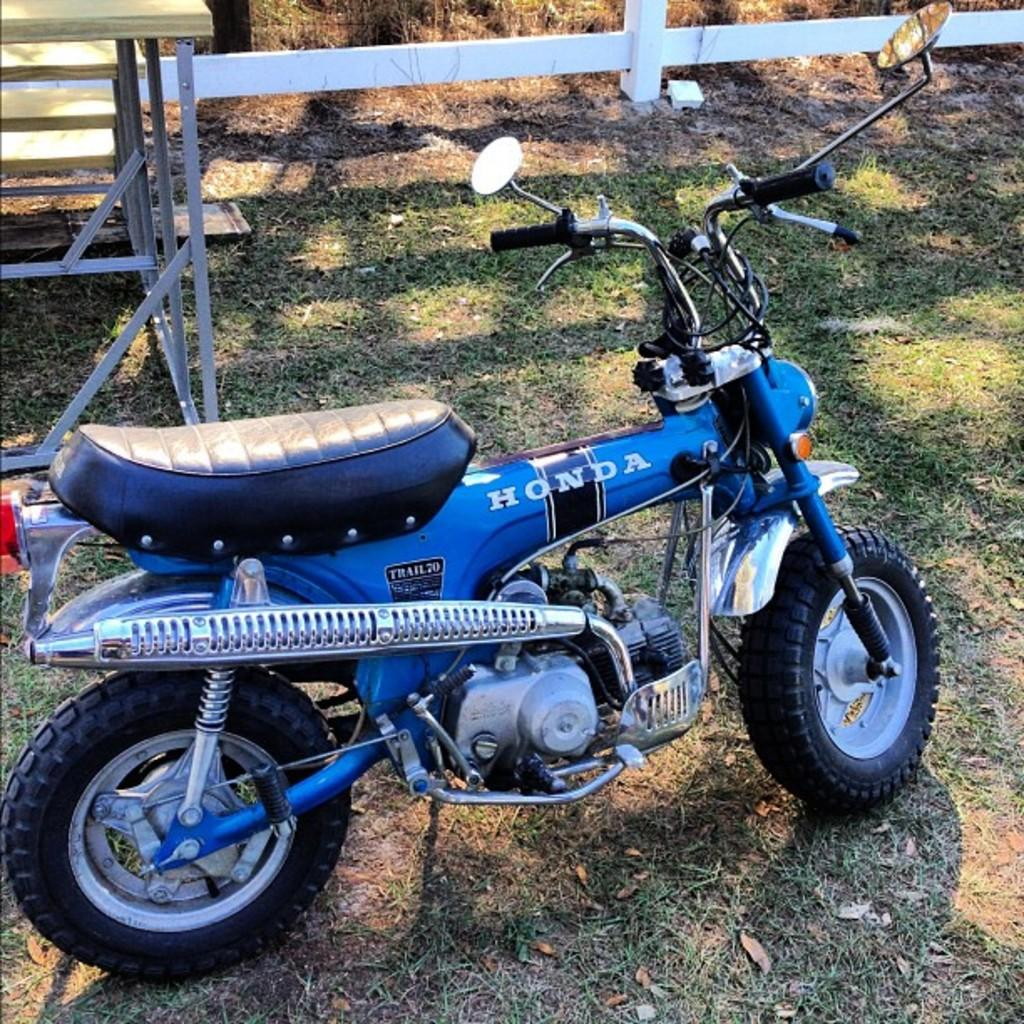What is the main object in the middle of the image? There is a bike in the middle of the image. What can be seen at the top of the image? There is a fencing gate at the top of the image. What is located on the left side of the image? There is a table on the left side of the image. What color is the chalk used to draw on the bike in the image? There is no chalk or drawing on the bike in the image. What is the mind's role in the image? The mind is not a physical object present in the image, so it does not have a role in the image. 